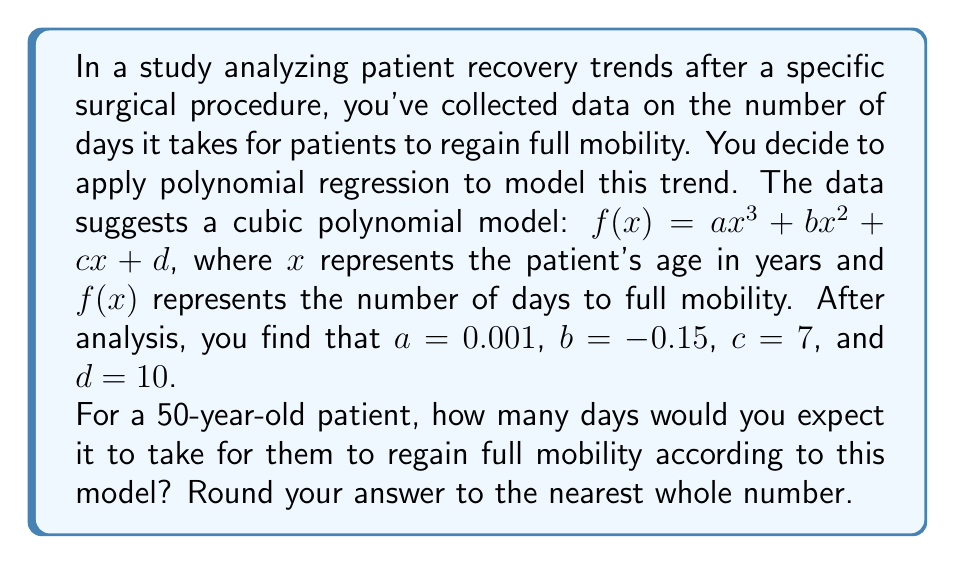What is the answer to this math problem? To solve this problem, we'll follow these steps:

1) We have the cubic polynomial model:
   $f(x) = ax^3 + bx^2 + cx + d$

2) We're given the values of the coefficients:
   $a = 0.001$
   $b = -0.15$
   $c = 7$
   $d = 10$

3) We need to calculate $f(50)$ since we're interested in a 50-year-old patient:

   $f(50) = 0.001(50^3) + (-0.15)(50^2) + 7(50) + 10$

4) Let's calculate each term:
   $0.001(50^3) = 0.001(125000) = 125$
   $-0.15(50^2) = -0.15(2500) = -375$
   $7(50) = 350$
   $10$ remains as is

5) Now, let's sum these terms:
   $f(50) = 125 + (-375) + 350 + 10 = 110$

6) The question asks to round to the nearest whole number, but our result is already a whole number.

Therefore, according to this model, we would expect a 50-year-old patient to take 110 days to regain full mobility.
Answer: 110 days 